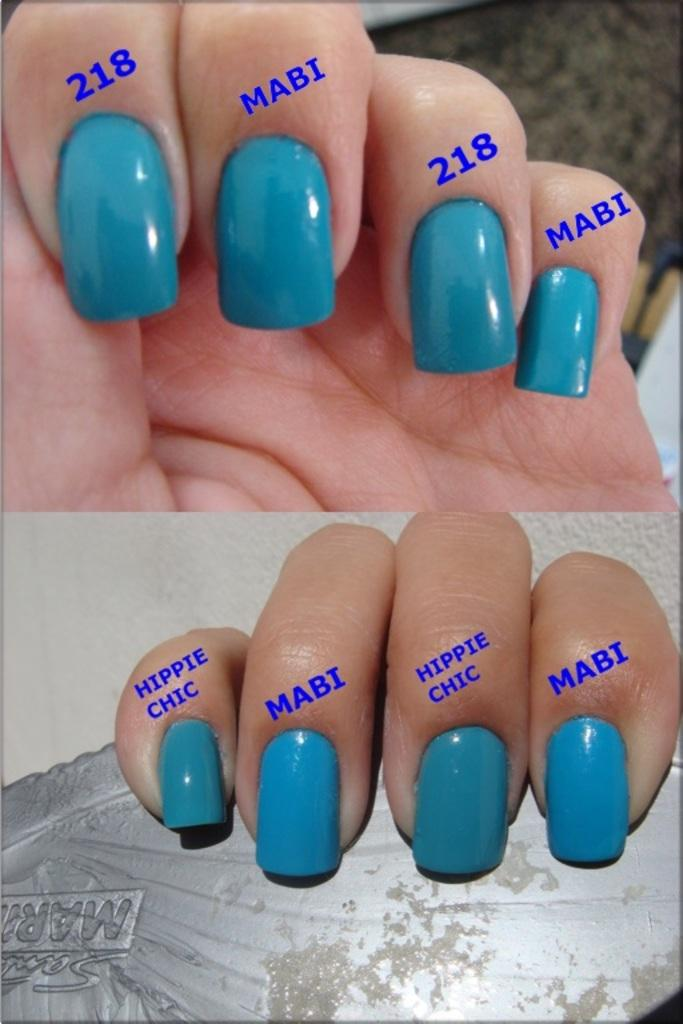<image>
Relay a brief, clear account of the picture shown. Fingernails with blue nail polish and various words above the nails including hippie chic, MABI, and 218. 